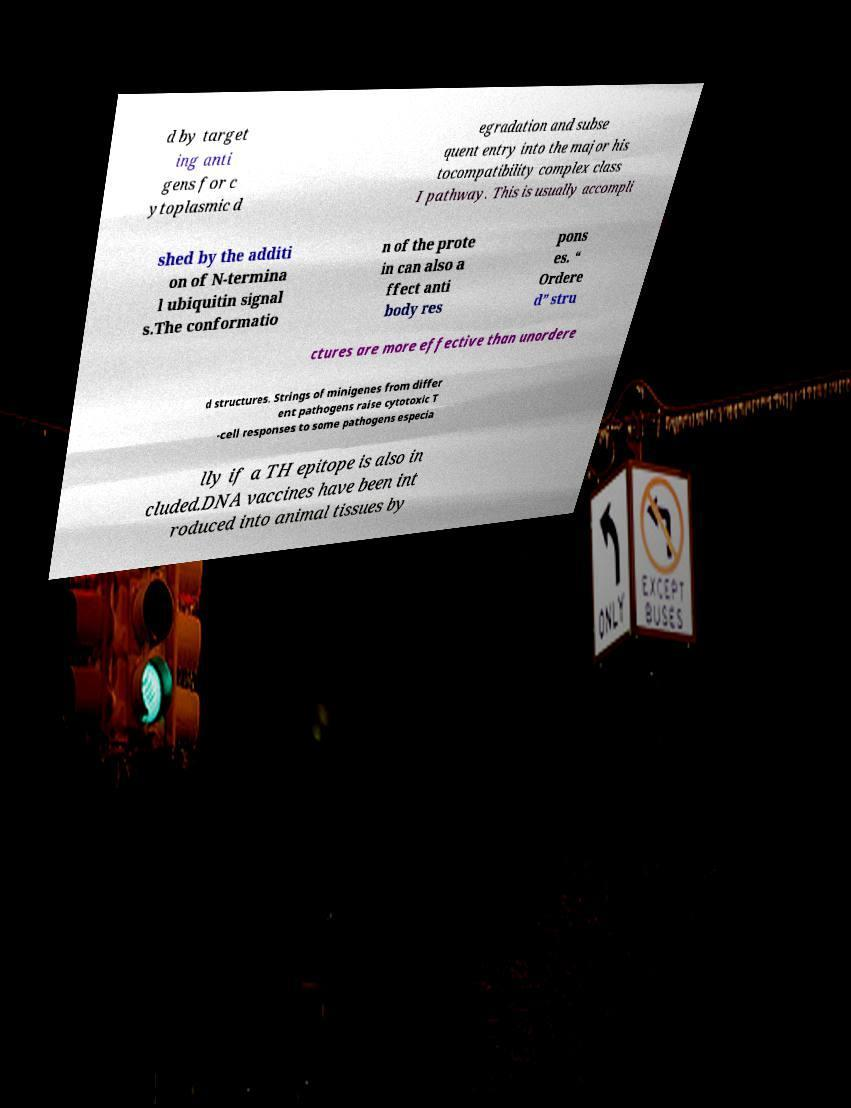Could you assist in decoding the text presented in this image and type it out clearly? d by target ing anti gens for c ytoplasmic d egradation and subse quent entry into the major his tocompatibility complex class I pathway. This is usually accompli shed by the additi on of N-termina l ubiquitin signal s.The conformatio n of the prote in can also a ffect anti body res pons es. “ Ordere d” stru ctures are more effective than unordere d structures. Strings of minigenes from differ ent pathogens raise cytotoxic T -cell responses to some pathogens especia lly if a TH epitope is also in cluded.DNA vaccines have been int roduced into animal tissues by 